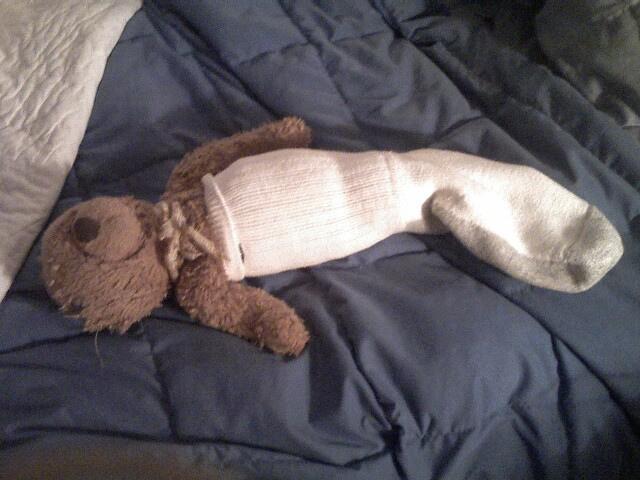How many stuffed animals are there?
Give a very brief answer. 1. 